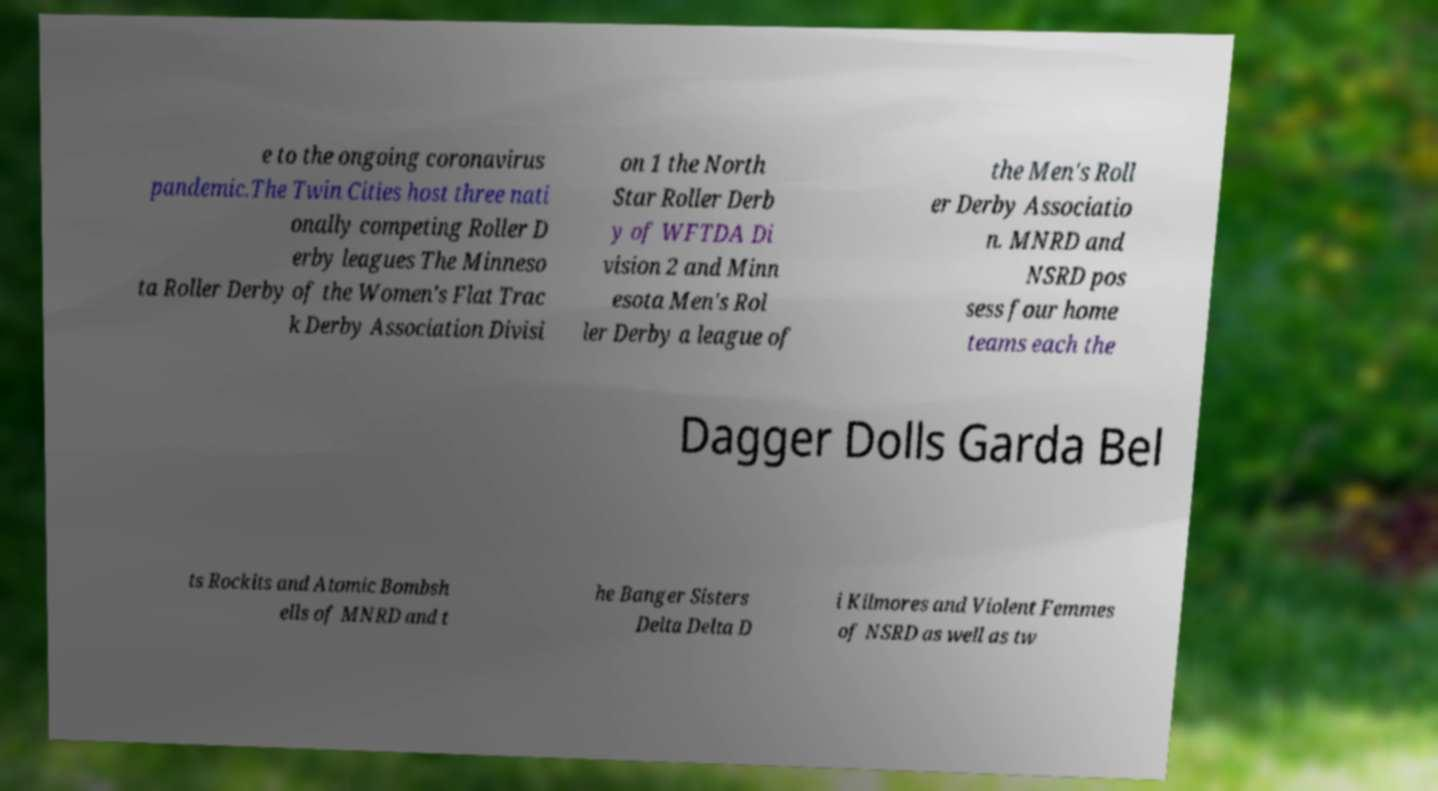Can you accurately transcribe the text from the provided image for me? e to the ongoing coronavirus pandemic.The Twin Cities host three nati onally competing Roller D erby leagues The Minneso ta Roller Derby of the Women's Flat Trac k Derby Association Divisi on 1 the North Star Roller Derb y of WFTDA Di vision 2 and Minn esota Men's Rol ler Derby a league of the Men's Roll er Derby Associatio n. MNRD and NSRD pos sess four home teams each the Dagger Dolls Garda Bel ts Rockits and Atomic Bombsh ells of MNRD and t he Banger Sisters Delta Delta D i Kilmores and Violent Femmes of NSRD as well as tw 